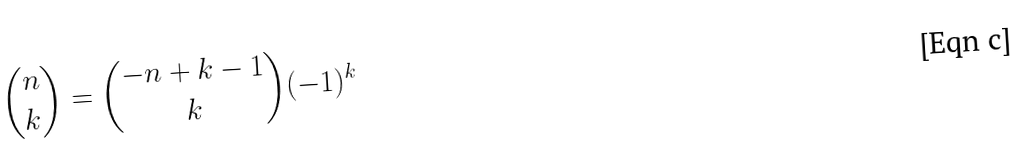<formula> <loc_0><loc_0><loc_500><loc_500>\binom { n } { k } = \binom { - n + k - 1 } { k } ( - 1 ) ^ { k }</formula> 